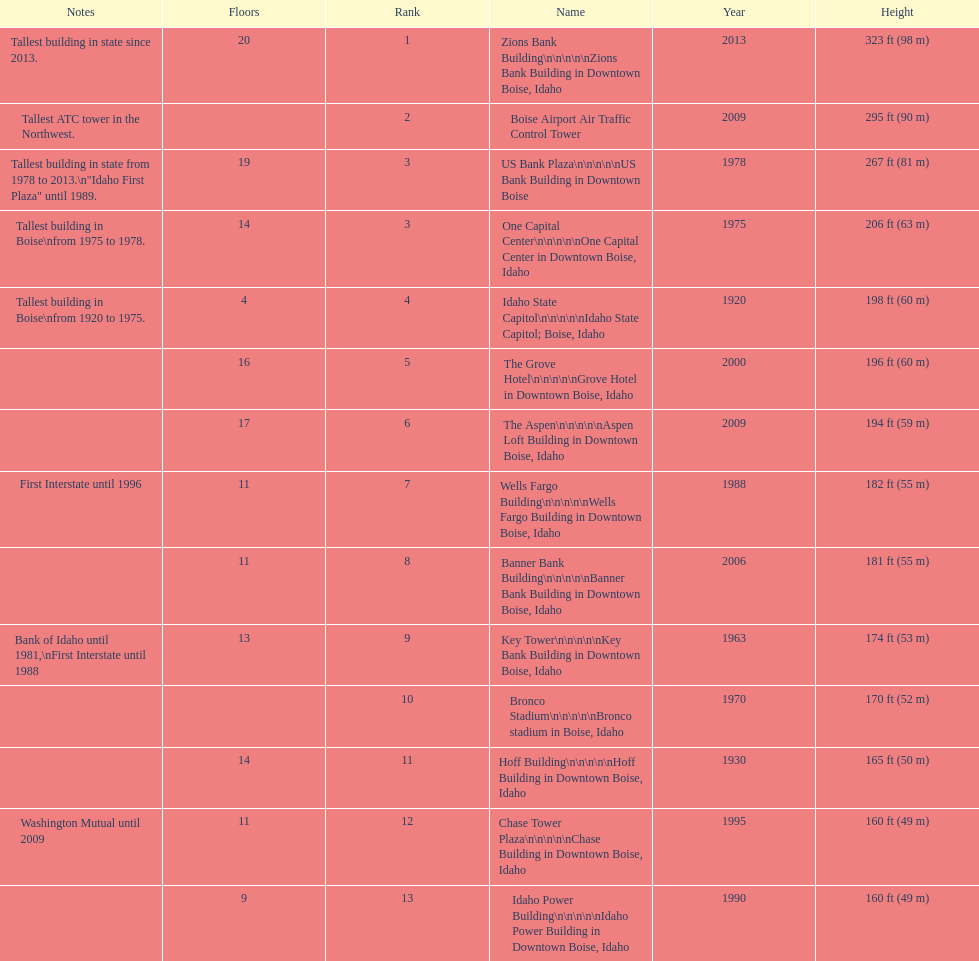What is the tallest building in bosie, idaho? Zions Bank Building Zions Bank Building in Downtown Boise, Idaho. 